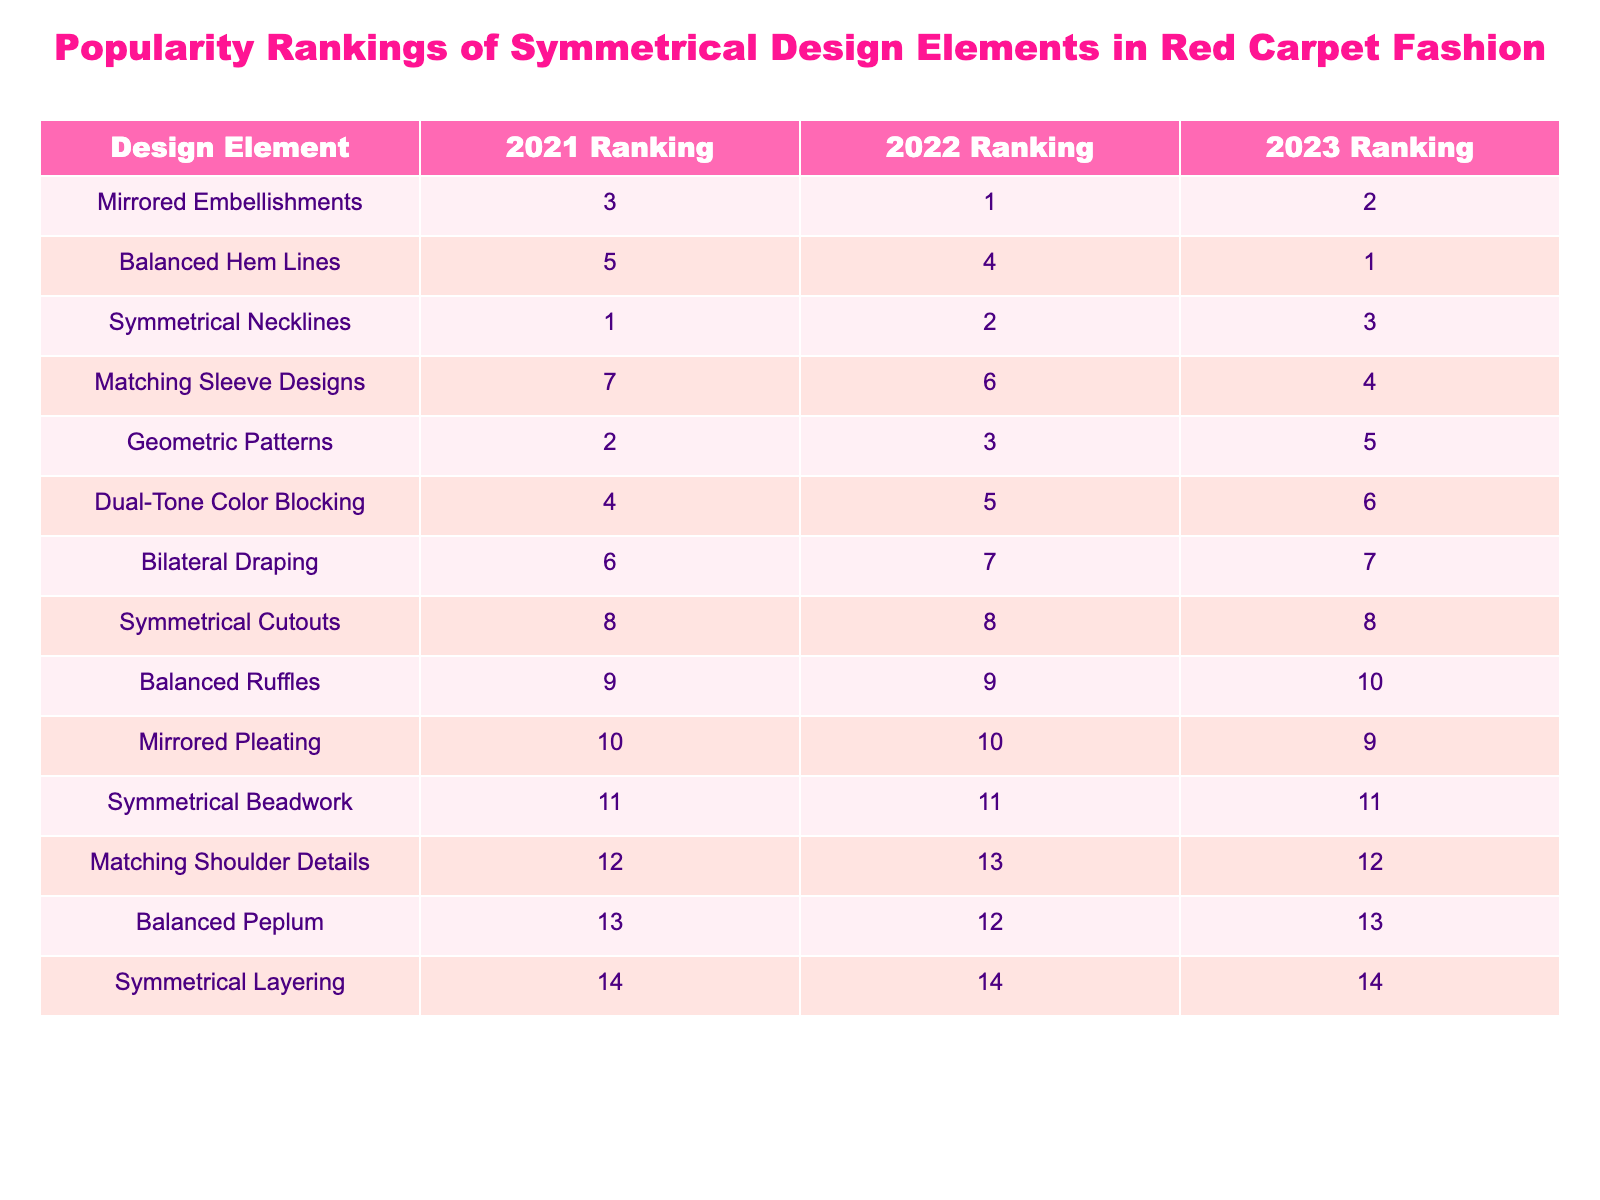What was the ranking of Mirrored Embellishments in 2022? The table indicates that Mirrored Embellishments held the 1st position in the 2022 Ranking.
Answer: 1 Which design element consistently ranked the same in all three years? By reviewing the table, Symmetrical Beadwork is noted to have maintained the 11th ranking across 2021, 2022, and 2023.
Answer: Yes Is there a design element that moved from 5th to 1st place? The table shows that Balanced Hem Lines moved from 5th in 2021 to 1st in 2023, indicating a significant improvement in its ranking.
Answer: Yes What is the average ranking of Balanced Ruffles over the three years? The rankings for Balanced Ruffles are 9 (2021), 9 (2022), and 10 (2023). Adding these gives 9 + 9 + 10 = 28, and dividing by 3 gives an average of 28/3 = 9.33.
Answer: 9.33 Which design elements improved their rankings from 2021 to 2023? By comparing the rankings, Balanced Hem Lines improved from 5th to 1st, and Mirrored Embellishments improved from 3rd to 2nd, illustrating their upward trends over the years.
Answer: Balanced Hem Lines and Mirrored Embellishments What is the total number of rankings contributed by the design element with the best average ranking? The best average ranking is held by Balanced Hem Lines with rankings of 5, 4, and 1, which sum to 5 + 4 + 1 = 10.
Answer: 10 Is there a design element that ranked last (i.e., 14th place) in 2021? The table indicates that Symmetrical Layering held the 14th position in 2021, confirming it as the design element ranked last that year.
Answer: Yes What was the change in ranking for Geometric Patterns from 2021 to 2023? Geometric Patterns ranked 2nd in 2021 and dropped to 5th in 2023, showing a decline of 3 rankings over the years.
Answer: Declined by 3 rankings Which design element has the lowest overall rank across all years? The lowest overall rank is held by Symmetrical Cutouts, which consistently ranks 8th in all three years.
Answer: Symmetrical Cutouts Which design element has the highest rank in 2023? The table shows that Balanced Hem Lines achieved the highest rank of 1st in 2023.
Answer: Balanced Hem Lines 